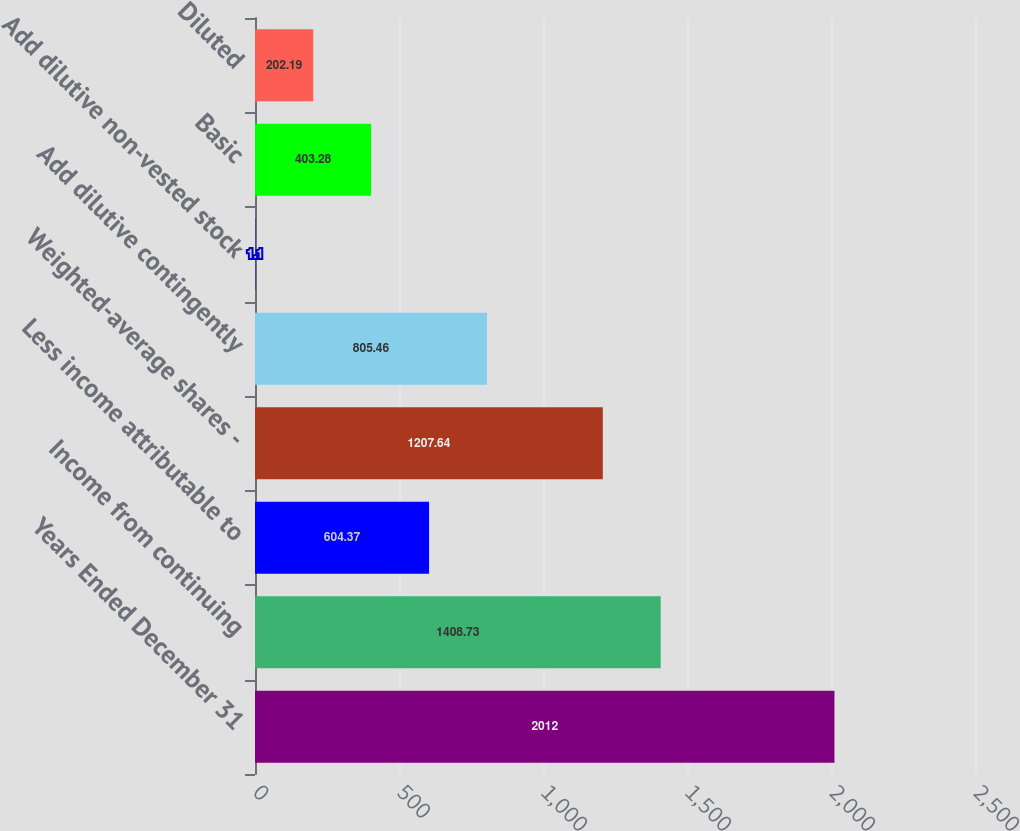<chart> <loc_0><loc_0><loc_500><loc_500><bar_chart><fcel>Years Ended December 31<fcel>Income from continuing<fcel>Less income attributable to<fcel>Weighted-average shares -<fcel>Add dilutive contingently<fcel>Add dilutive non-vested stock<fcel>Basic<fcel>Diluted<nl><fcel>2012<fcel>1408.73<fcel>604.37<fcel>1207.64<fcel>805.46<fcel>1.1<fcel>403.28<fcel>202.19<nl></chart> 